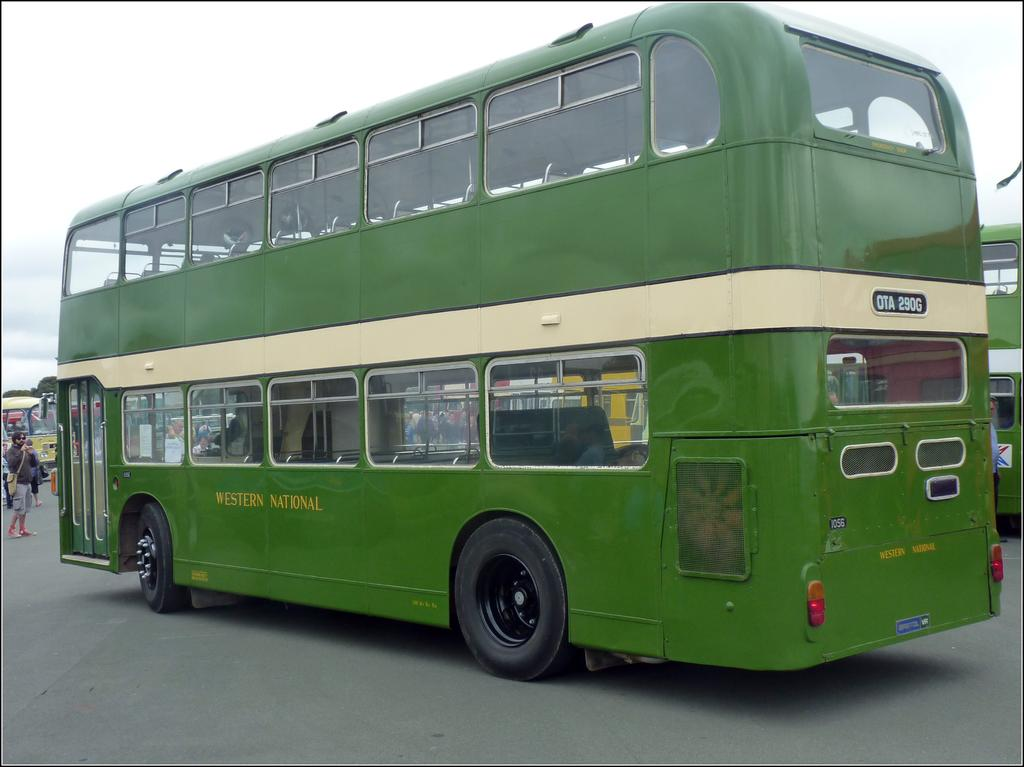What is the main subject in the center of the image? There is a bus in the center of the image. Can you describe anything on the left side of the image? There is a man on the left side of the image. What color are the man's toes in the image? There is no information about the man's toes in the image, as the focus is on the bus and the man's presence. 